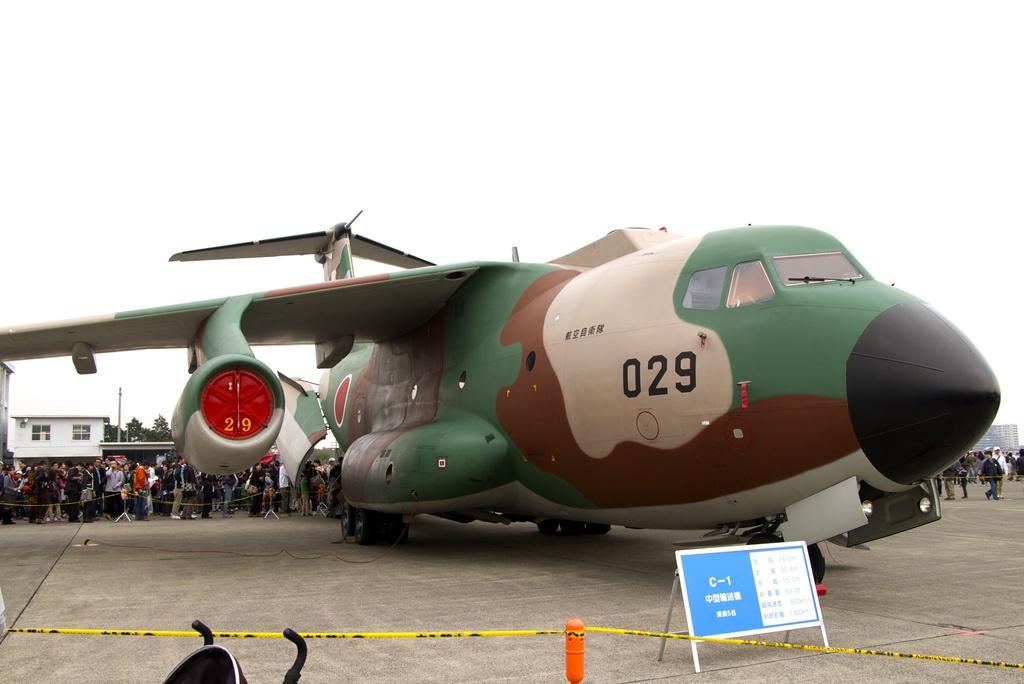<image>
Share a concise interpretation of the image provided. A multi-colored C-1 airplane, numbered 029, draws a huge crowd. 